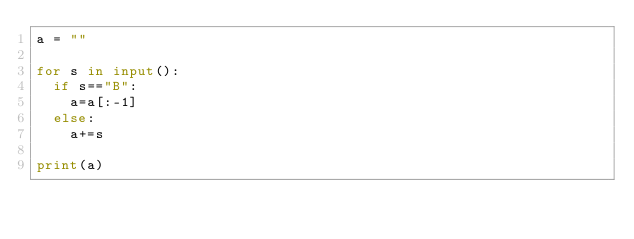<code> <loc_0><loc_0><loc_500><loc_500><_Python_>a = ""

for s in input():
  if s=="B":
    a=a[:-1]
  else:
    a+=s

print(a)</code> 